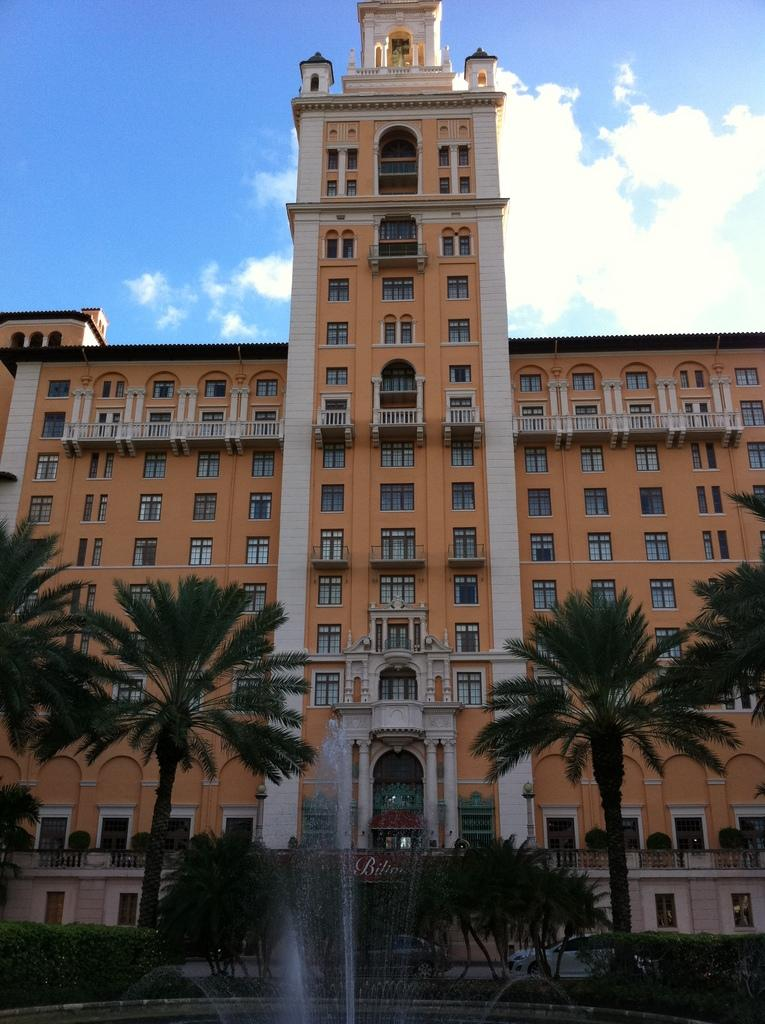What type of structure is present in the image? There is a building in the image. What is located in front of the building? There are trees and a fountain in front of the building. What can be seen at the top of the image? There are clouds visible at the top of the image. What is visible in the background of the image? The sky is visible in the image. What pets are visible in the image? There are no pets present in the image. What societal issues are being addressed in the image? The image does not depict any societal issues; it primarily shows a building, trees, a fountain, clouds, and the sky. 